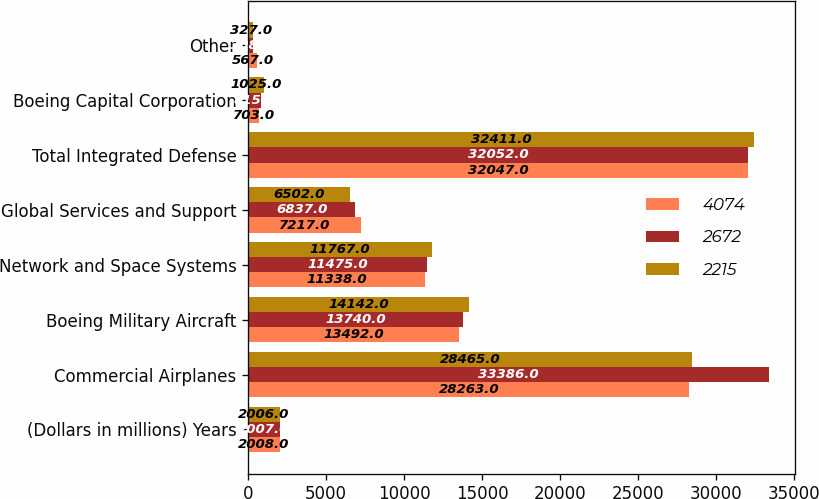<chart> <loc_0><loc_0><loc_500><loc_500><stacked_bar_chart><ecel><fcel>(Dollars in millions) Years<fcel>Commercial Airplanes<fcel>Boeing Military Aircraft<fcel>Network and Space Systems<fcel>Global Services and Support<fcel>Total Integrated Defense<fcel>Boeing Capital Corporation<fcel>Other<nl><fcel>4074<fcel>2008<fcel>28263<fcel>13492<fcel>11338<fcel>7217<fcel>32047<fcel>703<fcel>567<nl><fcel>2672<fcel>2007<fcel>33386<fcel>13740<fcel>11475<fcel>6837<fcel>32052<fcel>815<fcel>308<nl><fcel>2215<fcel>2006<fcel>28465<fcel>14142<fcel>11767<fcel>6502<fcel>32411<fcel>1025<fcel>327<nl></chart> 